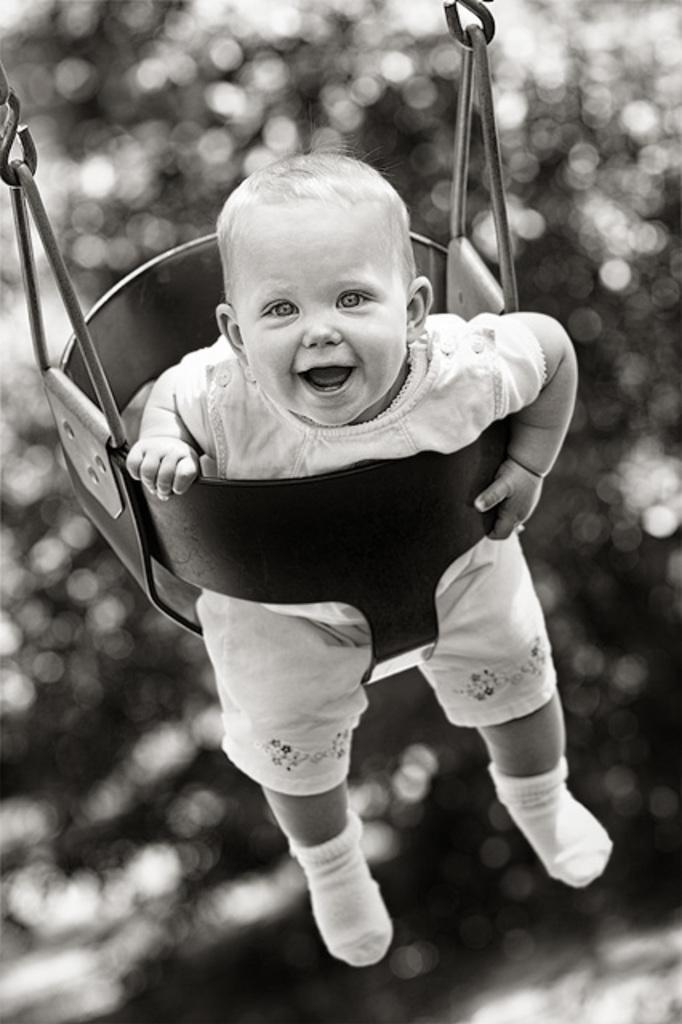What is the color scheme of the image? The image is in black and white. What can be seen in the image? There is a baby in the image. What is the baby wearing? The baby is wearing a white dress. What is the baby doing in the image? The baby is sitting on a swing and smiling. What can be seen in the background of the image? There are trees visible in the background. How is the background of the image depicted? The background is blurred. What is the governor's opinion on the existence of the branch in the image? There is no governor or branch present in the image, so it is not possible to determine their opinion. 